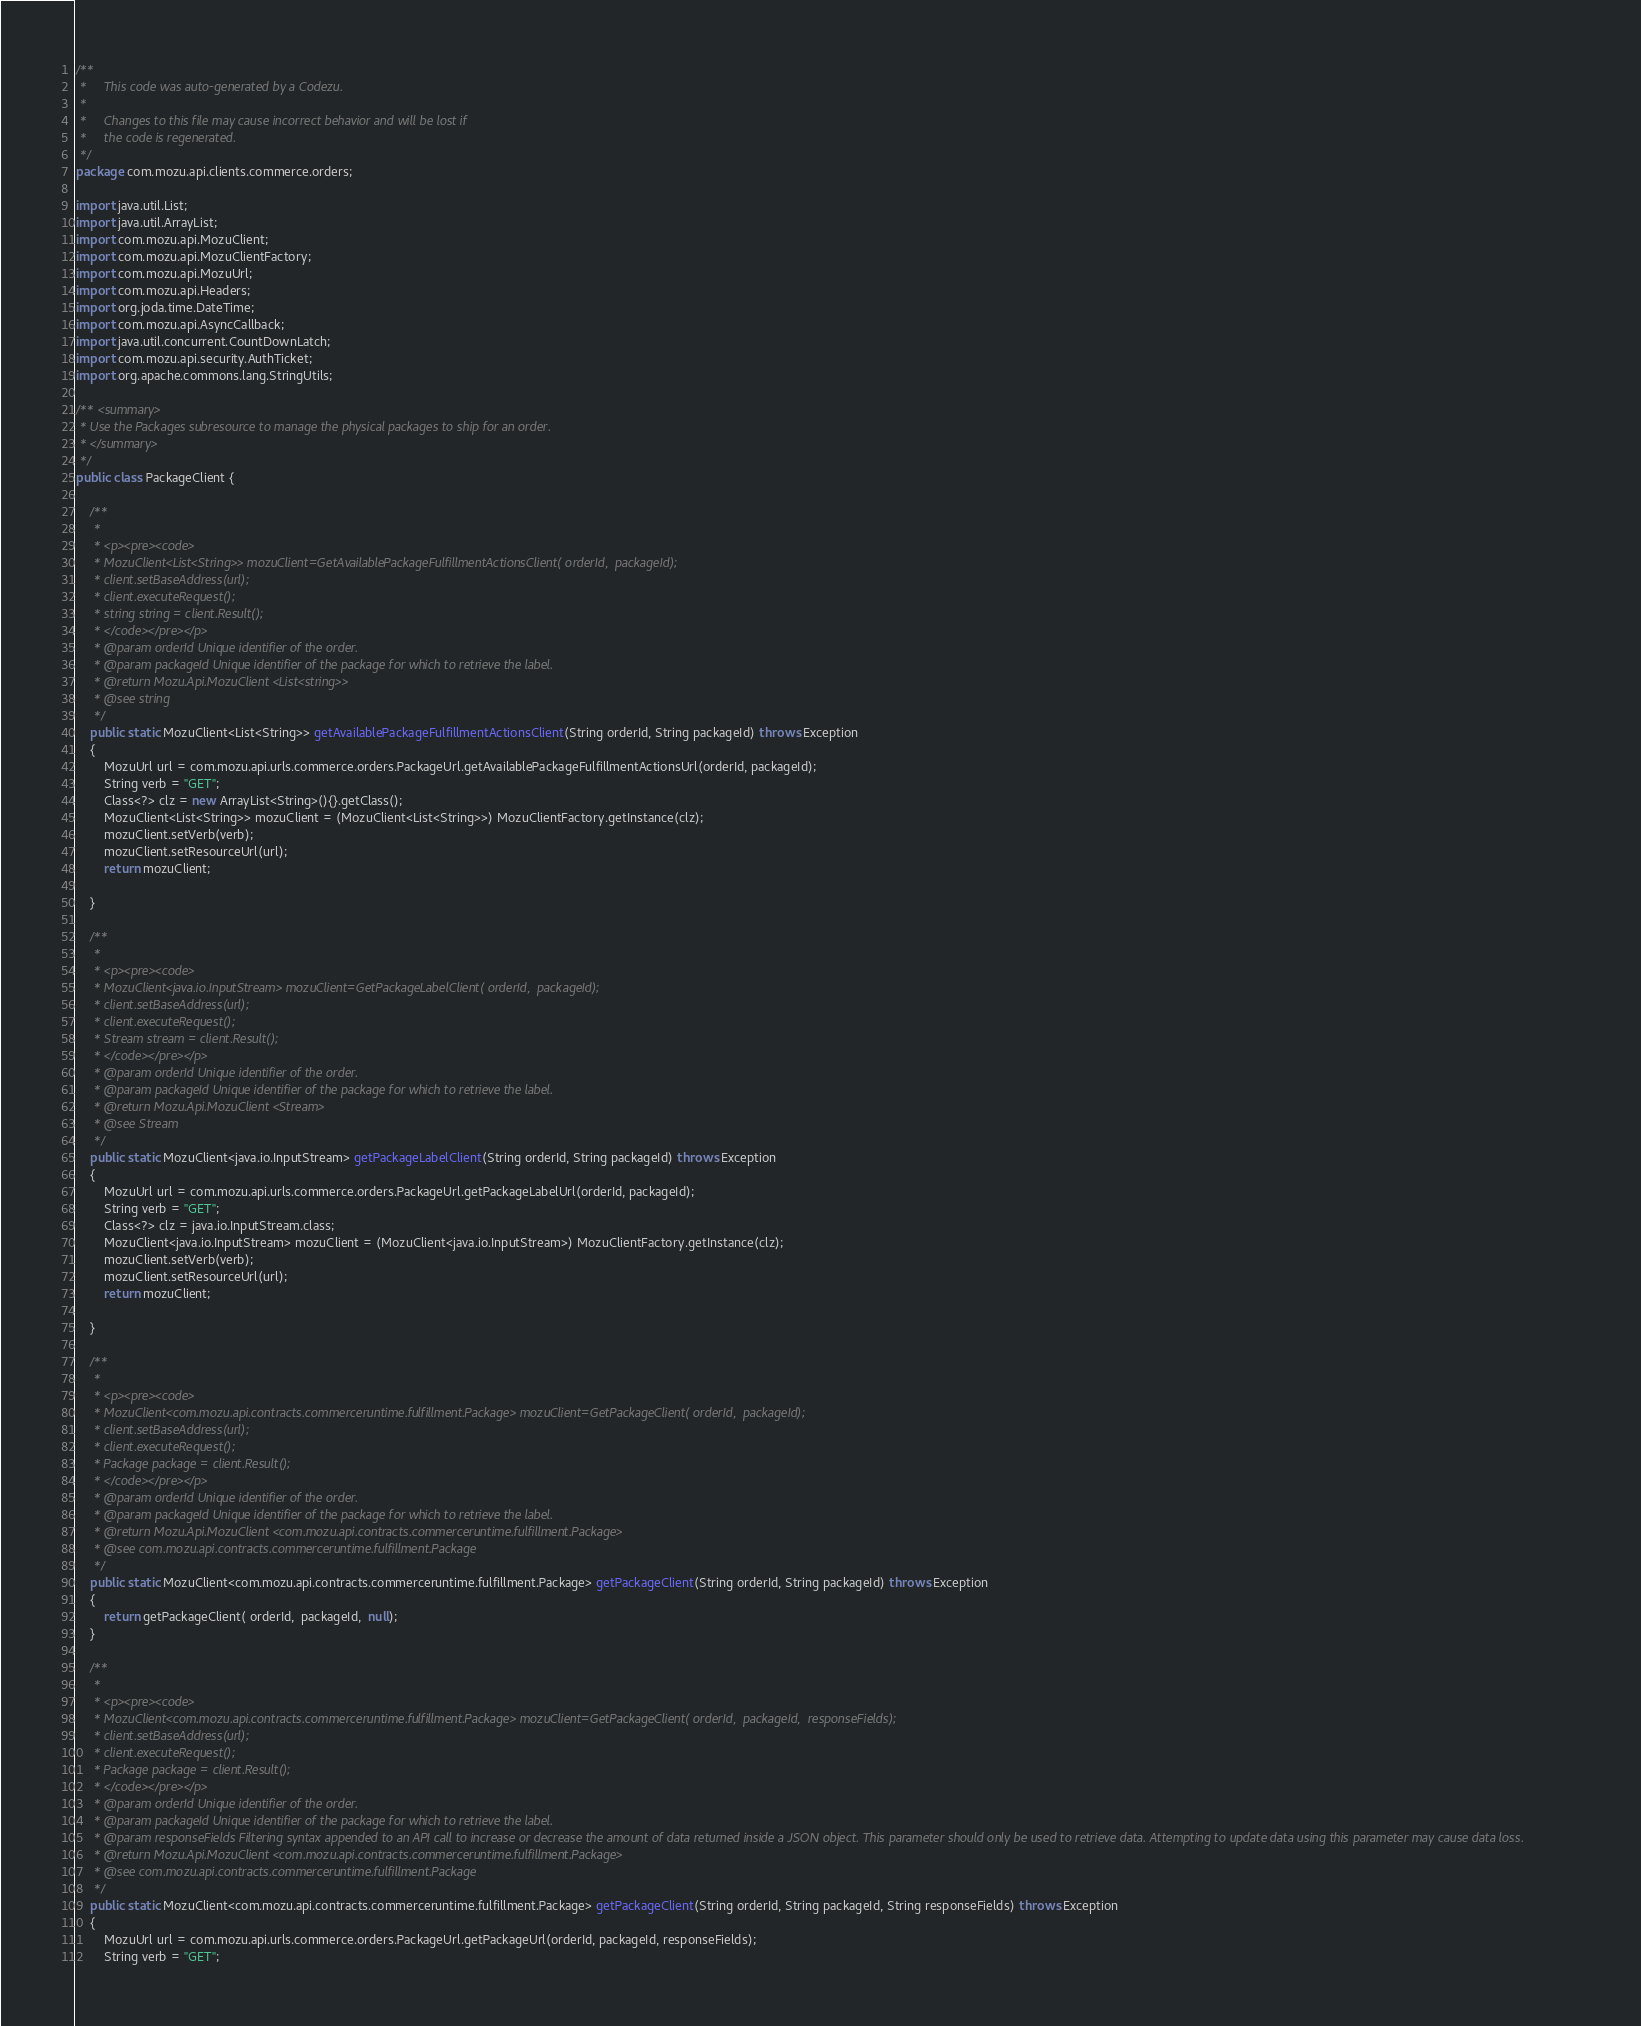Convert code to text. <code><loc_0><loc_0><loc_500><loc_500><_Java_>/**
 *     This code was auto-generated by a Codezu.     
 *
 *     Changes to this file may cause incorrect behavior and will be lost if
 *     the code is regenerated.
 */
package com.mozu.api.clients.commerce.orders;

import java.util.List;
import java.util.ArrayList;
import com.mozu.api.MozuClient;
import com.mozu.api.MozuClientFactory;
import com.mozu.api.MozuUrl;
import com.mozu.api.Headers;
import org.joda.time.DateTime;
import com.mozu.api.AsyncCallback;
import java.util.concurrent.CountDownLatch;
import com.mozu.api.security.AuthTicket;
import org.apache.commons.lang.StringUtils;

/** <summary>
 * Use the Packages subresource to manage the physical packages to ship for an order.
 * </summary>
 */
public class PackageClient {
	
	/**
	 * 
	 * <p><pre><code>
	 * MozuClient<List<String>> mozuClient=GetAvailablePackageFulfillmentActionsClient( orderId,  packageId);
	 * client.setBaseAddress(url);
	 * client.executeRequest();
	 * string string = client.Result();
	 * </code></pre></p>
	 * @param orderId Unique identifier of the order.
	 * @param packageId Unique identifier of the package for which to retrieve the label.
	 * @return Mozu.Api.MozuClient <List<string>>
	 * @see string
	 */
	public static MozuClient<List<String>> getAvailablePackageFulfillmentActionsClient(String orderId, String packageId) throws Exception
	{
		MozuUrl url = com.mozu.api.urls.commerce.orders.PackageUrl.getAvailablePackageFulfillmentActionsUrl(orderId, packageId);
		String verb = "GET";
		Class<?> clz = new ArrayList<String>(){}.getClass();
		MozuClient<List<String>> mozuClient = (MozuClient<List<String>>) MozuClientFactory.getInstance(clz);
		mozuClient.setVerb(verb);
		mozuClient.setResourceUrl(url);
		return mozuClient;

	}

	/**
	 * 
	 * <p><pre><code>
	 * MozuClient<java.io.InputStream> mozuClient=GetPackageLabelClient( orderId,  packageId);
	 * client.setBaseAddress(url);
	 * client.executeRequest();
	 * Stream stream = client.Result();
	 * </code></pre></p>
	 * @param orderId Unique identifier of the order.
	 * @param packageId Unique identifier of the package for which to retrieve the label.
	 * @return Mozu.Api.MozuClient <Stream>
	 * @see Stream
	 */
	public static MozuClient<java.io.InputStream> getPackageLabelClient(String orderId, String packageId) throws Exception
	{
		MozuUrl url = com.mozu.api.urls.commerce.orders.PackageUrl.getPackageLabelUrl(orderId, packageId);
		String verb = "GET";
		Class<?> clz = java.io.InputStream.class;
		MozuClient<java.io.InputStream> mozuClient = (MozuClient<java.io.InputStream>) MozuClientFactory.getInstance(clz);
		mozuClient.setVerb(verb);
		mozuClient.setResourceUrl(url);
		return mozuClient;

	}

	/**
	 * 
	 * <p><pre><code>
	 * MozuClient<com.mozu.api.contracts.commerceruntime.fulfillment.Package> mozuClient=GetPackageClient( orderId,  packageId);
	 * client.setBaseAddress(url);
	 * client.executeRequest();
	 * Package package = client.Result();
	 * </code></pre></p>
	 * @param orderId Unique identifier of the order.
	 * @param packageId Unique identifier of the package for which to retrieve the label.
	 * @return Mozu.Api.MozuClient <com.mozu.api.contracts.commerceruntime.fulfillment.Package>
	 * @see com.mozu.api.contracts.commerceruntime.fulfillment.Package
	 */
	public static MozuClient<com.mozu.api.contracts.commerceruntime.fulfillment.Package> getPackageClient(String orderId, String packageId) throws Exception
	{
		return getPackageClient( orderId,  packageId,  null);
	}

	/**
	 * 
	 * <p><pre><code>
	 * MozuClient<com.mozu.api.contracts.commerceruntime.fulfillment.Package> mozuClient=GetPackageClient( orderId,  packageId,  responseFields);
	 * client.setBaseAddress(url);
	 * client.executeRequest();
	 * Package package = client.Result();
	 * </code></pre></p>
	 * @param orderId Unique identifier of the order.
	 * @param packageId Unique identifier of the package for which to retrieve the label.
	 * @param responseFields Filtering syntax appended to an API call to increase or decrease the amount of data returned inside a JSON object. This parameter should only be used to retrieve data. Attempting to update data using this parameter may cause data loss.
	 * @return Mozu.Api.MozuClient <com.mozu.api.contracts.commerceruntime.fulfillment.Package>
	 * @see com.mozu.api.contracts.commerceruntime.fulfillment.Package
	 */
	public static MozuClient<com.mozu.api.contracts.commerceruntime.fulfillment.Package> getPackageClient(String orderId, String packageId, String responseFields) throws Exception
	{
		MozuUrl url = com.mozu.api.urls.commerce.orders.PackageUrl.getPackageUrl(orderId, packageId, responseFields);
		String verb = "GET";</code> 